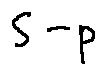Convert formula to latex. <formula><loc_0><loc_0><loc_500><loc_500>S - p</formula> 